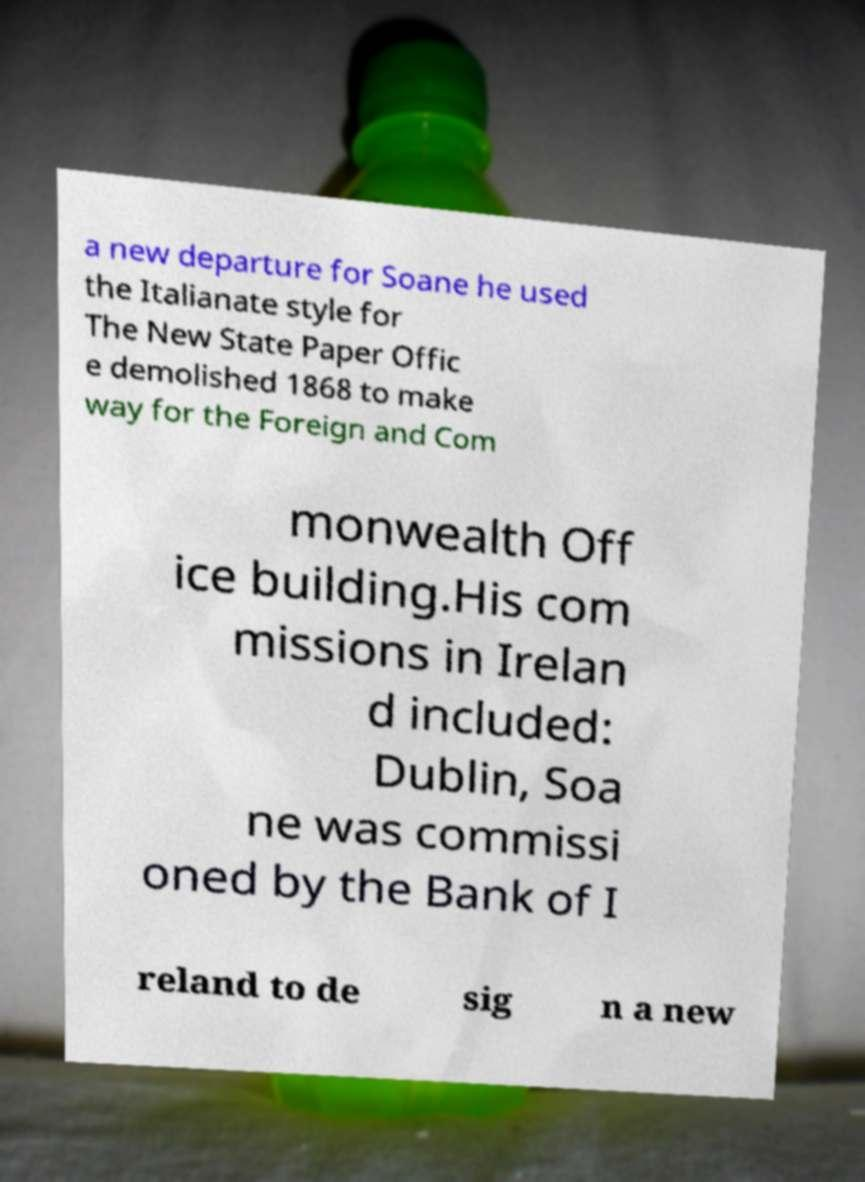Please identify and transcribe the text found in this image. a new departure for Soane he used the Italianate style for The New State Paper Offic e demolished 1868 to make way for the Foreign and Com monwealth Off ice building.His com missions in Irelan d included: Dublin, Soa ne was commissi oned by the Bank of I reland to de sig n a new 